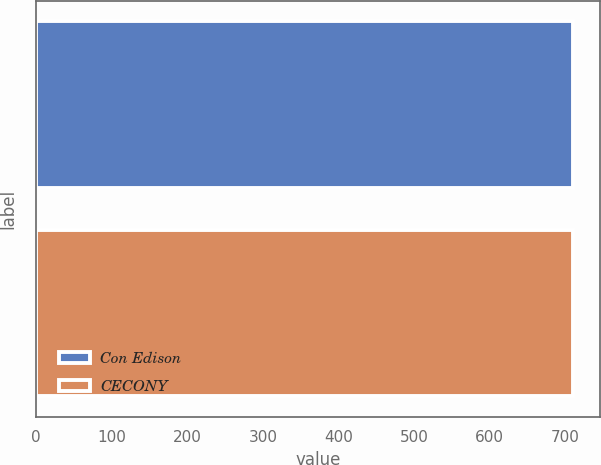Convert chart. <chart><loc_0><loc_0><loc_500><loc_500><bar_chart><fcel>Con Edison<fcel>CECONY<nl><fcel>710<fcel>710.1<nl></chart> 